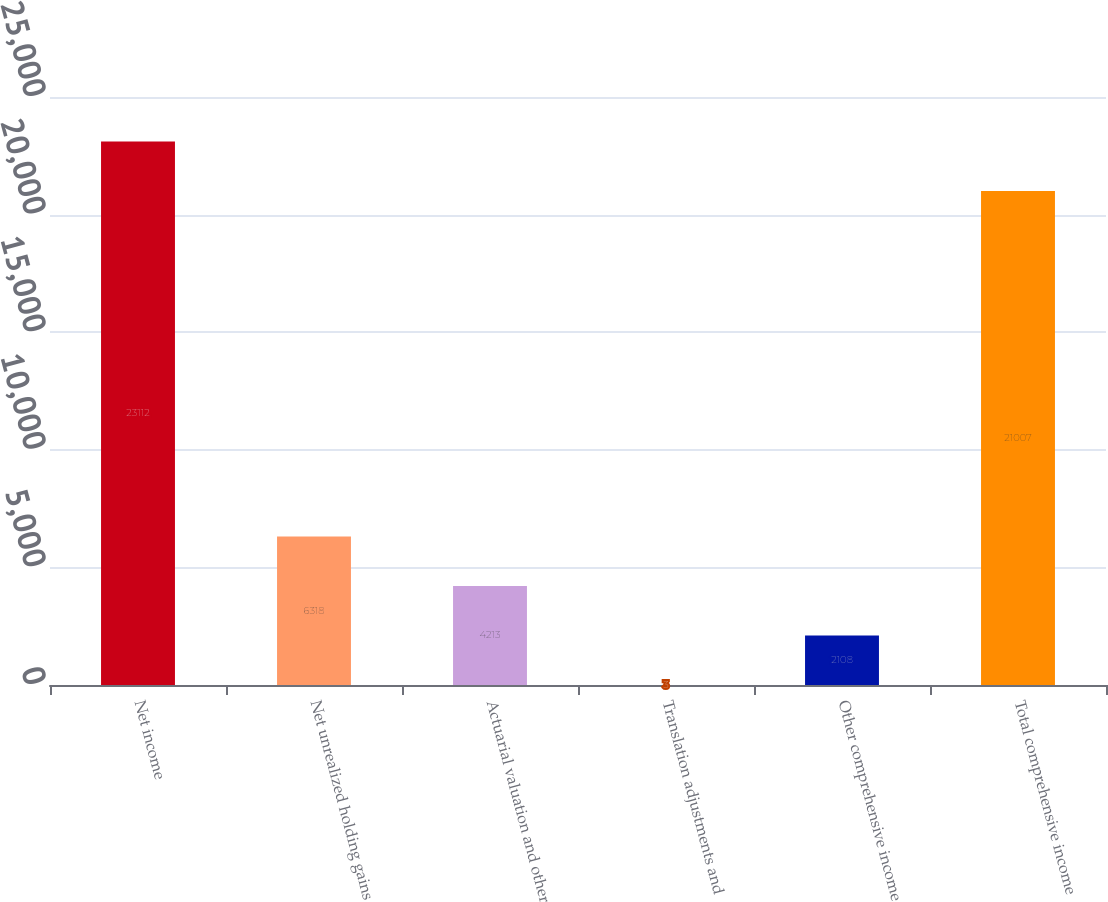Convert chart to OTSL. <chart><loc_0><loc_0><loc_500><loc_500><bar_chart><fcel>Net income<fcel>Net unrealized holding gains<fcel>Actuarial valuation and other<fcel>Translation adjustments and<fcel>Other comprehensive income<fcel>Total comprehensive income<nl><fcel>23112<fcel>6318<fcel>4213<fcel>3<fcel>2108<fcel>21007<nl></chart> 